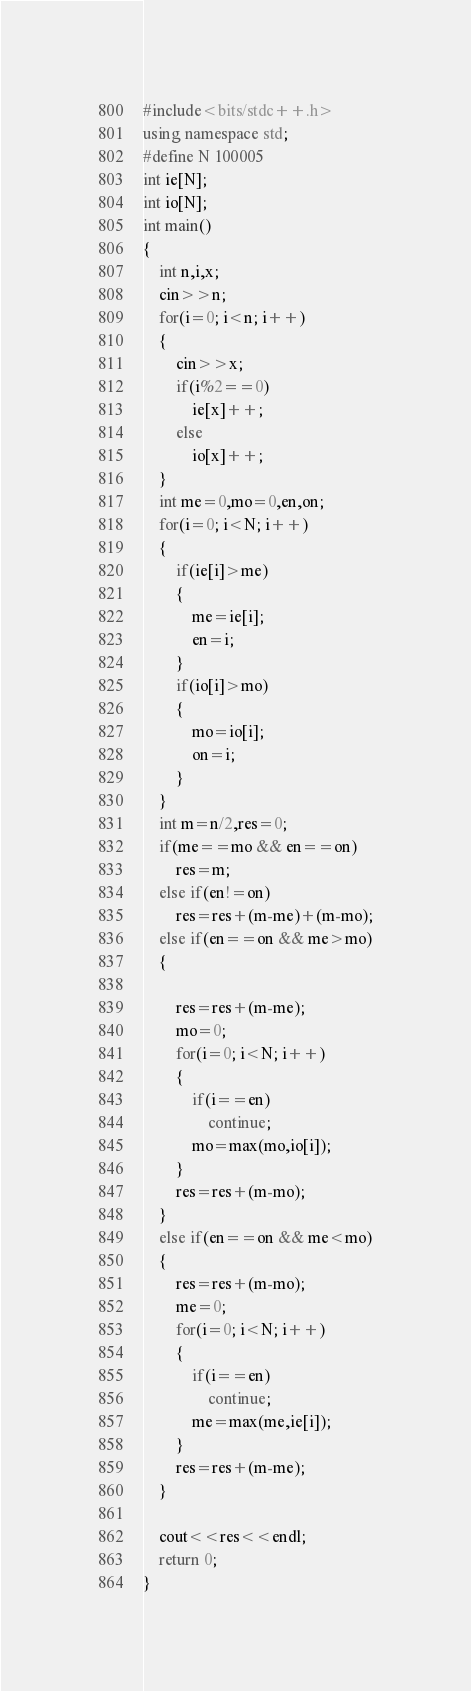<code> <loc_0><loc_0><loc_500><loc_500><_C++_>#include<bits/stdc++.h>
using namespace std;
#define N 100005
int ie[N];
int io[N];
int main()
{
    int n,i,x;
    cin>>n;
    for(i=0; i<n; i++)
    {
        cin>>x;
        if(i%2==0)
            ie[x]++;
        else
            io[x]++;
    }
    int me=0,mo=0,en,on;
    for(i=0; i<N; i++)
    {
        if(ie[i]>me)
        {
            me=ie[i];
            en=i;
        }
        if(io[i]>mo)
        {
            mo=io[i];
            on=i;
        }
    }
    int m=n/2,res=0;
    if(me==mo && en==on)
        res=m;
    else if(en!=on)
        res=res+(m-me)+(m-mo);
    else if(en==on && me>mo)
    {

        res=res+(m-me);
        mo=0;
        for(i=0; i<N; i++)
        {
            if(i==en)
                continue;
            mo=max(mo,io[i]);
        }
        res=res+(m-mo);
    }
    else if(en==on && me<mo)
    {
        res=res+(m-mo);
        me=0;
        for(i=0; i<N; i++)
        {
            if(i==en)
                continue;
            me=max(me,ie[i]);
        }
        res=res+(m-me);
    }

    cout<<res<<endl;
    return 0;
}
</code> 